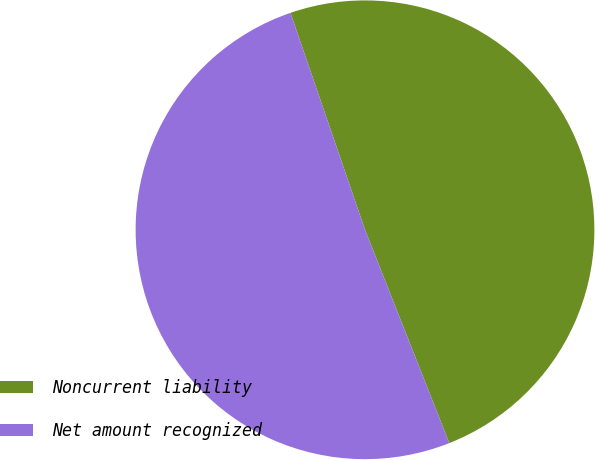Convert chart. <chart><loc_0><loc_0><loc_500><loc_500><pie_chart><fcel>Noncurrent liability<fcel>Net amount recognized<nl><fcel>49.28%<fcel>50.72%<nl></chart> 